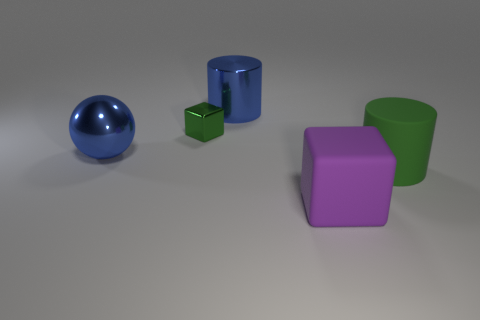What number of objects are either cylinders to the right of the large purple thing or balls that are behind the big green cylinder?
Your answer should be compact. 2. There is another object that is the same shape as the green shiny thing; what material is it?
Give a very brief answer. Rubber. What number of matte things are either blue cylinders or large gray cubes?
Ensure brevity in your answer.  0. What is the shape of the tiny green thing that is the same material as the sphere?
Make the answer very short. Cube. What number of other blue metallic objects have the same shape as the small object?
Ensure brevity in your answer.  0. Does the green object to the left of the large green cylinder have the same shape as the object on the left side of the tiny green metal block?
Your answer should be very brief. No. What number of things are either matte blocks or large cylinders that are in front of the metallic ball?
Your answer should be very brief. 2. The metallic thing that is the same color as the big rubber cylinder is what shape?
Give a very brief answer. Cube. How many green rubber objects are the same size as the green cylinder?
Your answer should be compact. 0. What number of yellow objects are either large rubber cubes or spheres?
Your answer should be very brief. 0. 